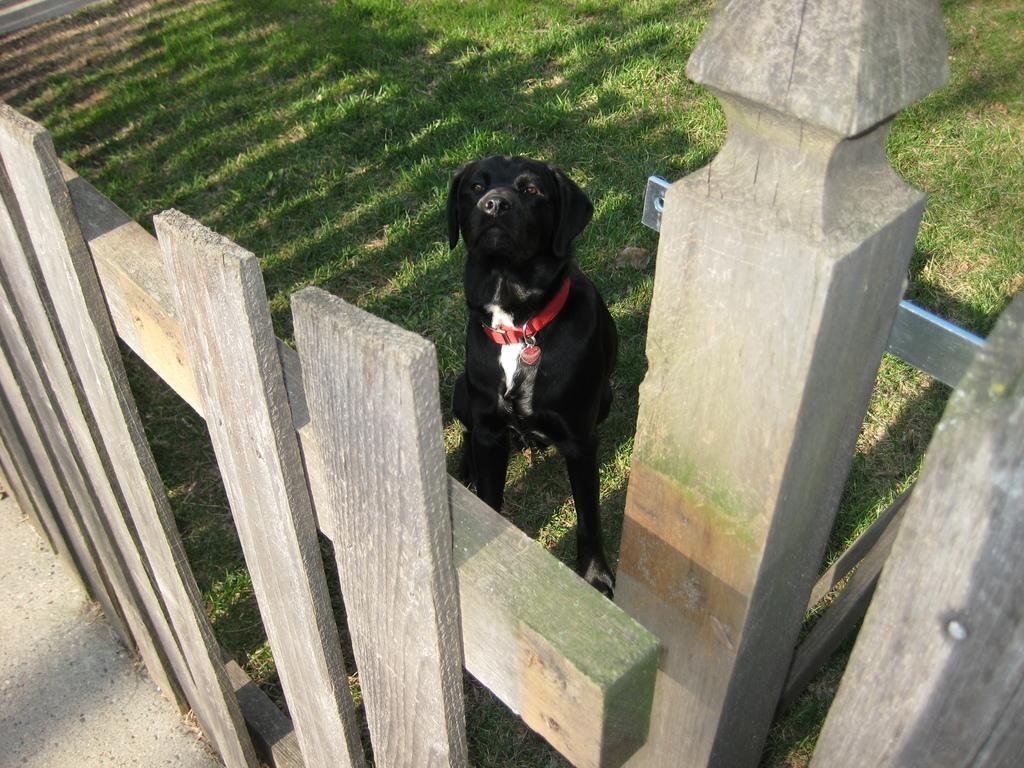Could you give a brief overview of what you see in this image? In this image we can see a fencing. There is a metal object is attached to the wooden object. There is a grassy land in the image. There is a dog in the image. 